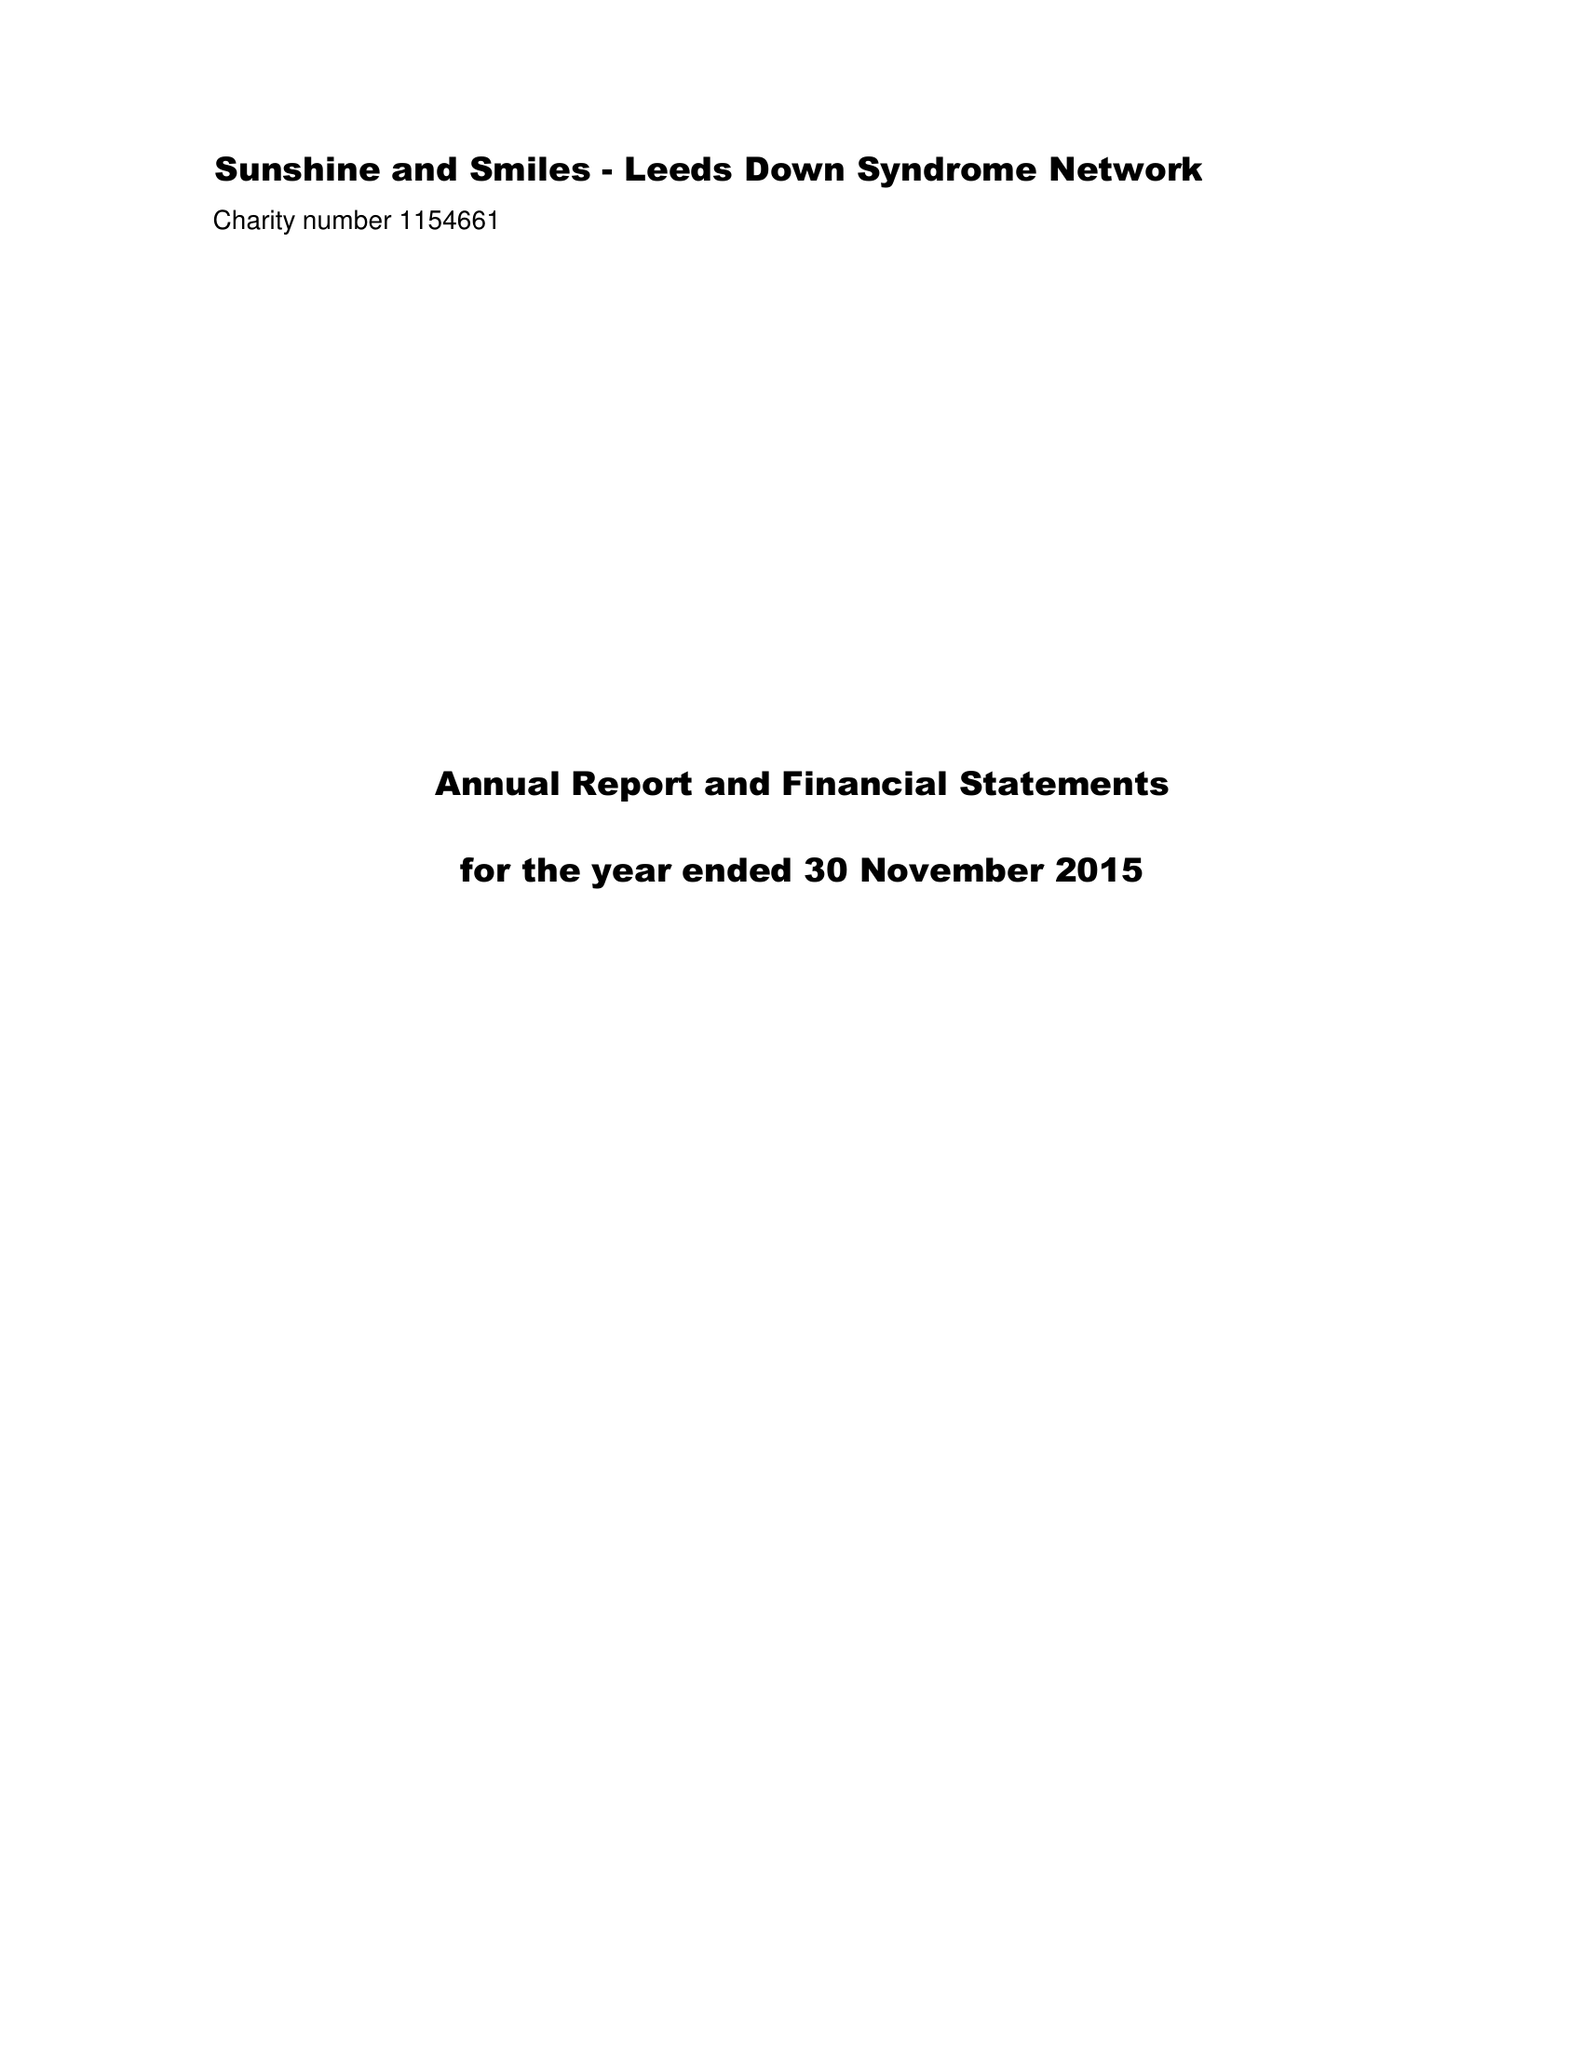What is the value for the spending_annually_in_british_pounds?
Answer the question using a single word or phrase. 44682.00 